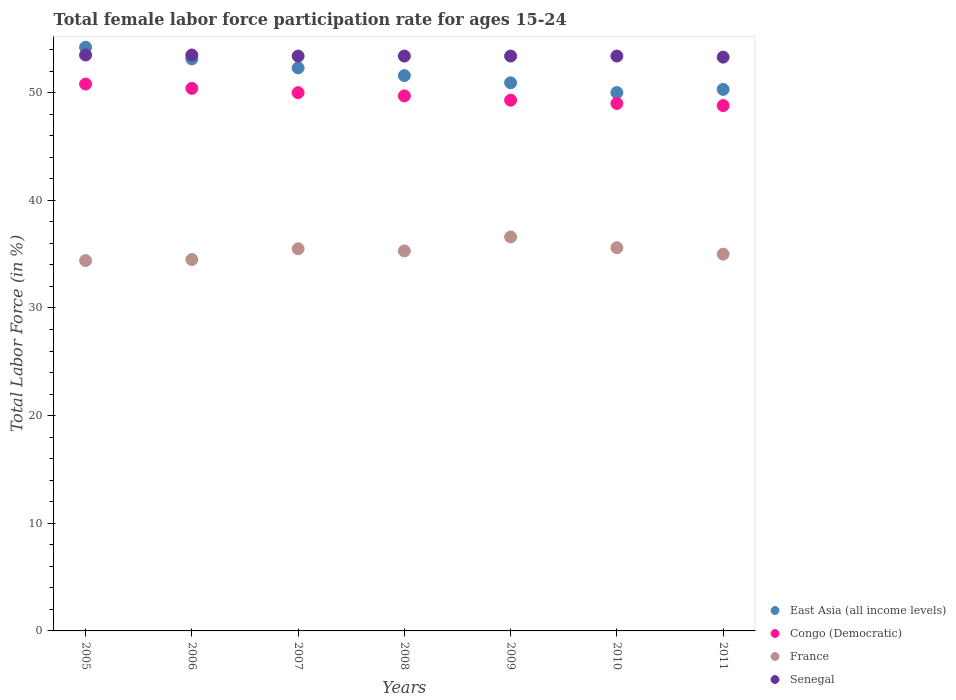How many different coloured dotlines are there?
Ensure brevity in your answer.  4. What is the female labor force participation rate in France in 2010?
Ensure brevity in your answer.  35.6. Across all years, what is the maximum female labor force participation rate in Senegal?
Ensure brevity in your answer.  53.5. Across all years, what is the minimum female labor force participation rate in France?
Give a very brief answer. 34.4. In which year was the female labor force participation rate in France maximum?
Keep it short and to the point. 2009. What is the total female labor force participation rate in France in the graph?
Your response must be concise. 246.9. What is the difference between the female labor force participation rate in Congo (Democratic) in 2005 and that in 2007?
Your response must be concise. 0.8. What is the difference between the female labor force participation rate in East Asia (all income levels) in 2010 and the female labor force participation rate in France in 2008?
Your response must be concise. 14.71. What is the average female labor force participation rate in Senegal per year?
Ensure brevity in your answer.  53.41. In the year 2011, what is the difference between the female labor force participation rate in Congo (Democratic) and female labor force participation rate in France?
Provide a short and direct response. 13.8. In how many years, is the female labor force participation rate in East Asia (all income levels) greater than 48 %?
Your response must be concise. 7. What is the ratio of the female labor force participation rate in Congo (Democratic) in 2005 to that in 2011?
Ensure brevity in your answer.  1.04. Is the difference between the female labor force participation rate in Congo (Democratic) in 2006 and 2007 greater than the difference between the female labor force participation rate in France in 2006 and 2007?
Offer a very short reply. Yes. What is the difference between the highest and the lowest female labor force participation rate in Congo (Democratic)?
Provide a short and direct response. 2. Is it the case that in every year, the sum of the female labor force participation rate in Senegal and female labor force participation rate in France  is greater than the female labor force participation rate in East Asia (all income levels)?
Give a very brief answer. Yes. Is the female labor force participation rate in East Asia (all income levels) strictly greater than the female labor force participation rate in Senegal over the years?
Keep it short and to the point. No. Is the female labor force participation rate in East Asia (all income levels) strictly less than the female labor force participation rate in France over the years?
Keep it short and to the point. No. How many dotlines are there?
Offer a very short reply. 4. What is the difference between two consecutive major ticks on the Y-axis?
Your answer should be compact. 10. Where does the legend appear in the graph?
Make the answer very short. Bottom right. How many legend labels are there?
Your response must be concise. 4. What is the title of the graph?
Give a very brief answer. Total female labor force participation rate for ages 15-24. What is the label or title of the X-axis?
Make the answer very short. Years. What is the label or title of the Y-axis?
Your answer should be very brief. Total Labor Force (in %). What is the Total Labor Force (in %) in East Asia (all income levels) in 2005?
Provide a succinct answer. 54.22. What is the Total Labor Force (in %) in Congo (Democratic) in 2005?
Your response must be concise. 50.8. What is the Total Labor Force (in %) of France in 2005?
Provide a succinct answer. 34.4. What is the Total Labor Force (in %) in Senegal in 2005?
Your answer should be compact. 53.5. What is the Total Labor Force (in %) in East Asia (all income levels) in 2006?
Ensure brevity in your answer.  53.13. What is the Total Labor Force (in %) of Congo (Democratic) in 2006?
Make the answer very short. 50.4. What is the Total Labor Force (in %) in France in 2006?
Your response must be concise. 34.5. What is the Total Labor Force (in %) of Senegal in 2006?
Your response must be concise. 53.5. What is the Total Labor Force (in %) of East Asia (all income levels) in 2007?
Make the answer very short. 52.3. What is the Total Labor Force (in %) in France in 2007?
Your answer should be very brief. 35.5. What is the Total Labor Force (in %) in Senegal in 2007?
Your answer should be compact. 53.4. What is the Total Labor Force (in %) in East Asia (all income levels) in 2008?
Provide a succinct answer. 51.59. What is the Total Labor Force (in %) of Congo (Democratic) in 2008?
Your answer should be compact. 49.7. What is the Total Labor Force (in %) in France in 2008?
Give a very brief answer. 35.3. What is the Total Labor Force (in %) in Senegal in 2008?
Your answer should be very brief. 53.4. What is the Total Labor Force (in %) of East Asia (all income levels) in 2009?
Offer a very short reply. 50.92. What is the Total Labor Force (in %) in Congo (Democratic) in 2009?
Keep it short and to the point. 49.3. What is the Total Labor Force (in %) of France in 2009?
Provide a short and direct response. 36.6. What is the Total Labor Force (in %) in Senegal in 2009?
Keep it short and to the point. 53.4. What is the Total Labor Force (in %) in East Asia (all income levels) in 2010?
Provide a succinct answer. 50.01. What is the Total Labor Force (in %) of Congo (Democratic) in 2010?
Your answer should be very brief. 49. What is the Total Labor Force (in %) of France in 2010?
Offer a very short reply. 35.6. What is the Total Labor Force (in %) in Senegal in 2010?
Ensure brevity in your answer.  53.4. What is the Total Labor Force (in %) in East Asia (all income levels) in 2011?
Ensure brevity in your answer.  50.31. What is the Total Labor Force (in %) of Congo (Democratic) in 2011?
Your response must be concise. 48.8. What is the Total Labor Force (in %) of France in 2011?
Provide a succinct answer. 35. What is the Total Labor Force (in %) in Senegal in 2011?
Provide a short and direct response. 53.3. Across all years, what is the maximum Total Labor Force (in %) in East Asia (all income levels)?
Ensure brevity in your answer.  54.22. Across all years, what is the maximum Total Labor Force (in %) of Congo (Democratic)?
Provide a short and direct response. 50.8. Across all years, what is the maximum Total Labor Force (in %) of France?
Ensure brevity in your answer.  36.6. Across all years, what is the maximum Total Labor Force (in %) in Senegal?
Provide a short and direct response. 53.5. Across all years, what is the minimum Total Labor Force (in %) of East Asia (all income levels)?
Your answer should be compact. 50.01. Across all years, what is the minimum Total Labor Force (in %) of Congo (Democratic)?
Offer a terse response. 48.8. Across all years, what is the minimum Total Labor Force (in %) in France?
Ensure brevity in your answer.  34.4. Across all years, what is the minimum Total Labor Force (in %) in Senegal?
Keep it short and to the point. 53.3. What is the total Total Labor Force (in %) in East Asia (all income levels) in the graph?
Provide a succinct answer. 362.47. What is the total Total Labor Force (in %) of Congo (Democratic) in the graph?
Your response must be concise. 348. What is the total Total Labor Force (in %) in France in the graph?
Offer a terse response. 246.9. What is the total Total Labor Force (in %) of Senegal in the graph?
Your answer should be compact. 373.9. What is the difference between the Total Labor Force (in %) of East Asia (all income levels) in 2005 and that in 2006?
Your answer should be very brief. 1.08. What is the difference between the Total Labor Force (in %) of Congo (Democratic) in 2005 and that in 2006?
Provide a succinct answer. 0.4. What is the difference between the Total Labor Force (in %) in Senegal in 2005 and that in 2006?
Make the answer very short. 0. What is the difference between the Total Labor Force (in %) of East Asia (all income levels) in 2005 and that in 2007?
Offer a terse response. 1.92. What is the difference between the Total Labor Force (in %) in France in 2005 and that in 2007?
Offer a terse response. -1.1. What is the difference between the Total Labor Force (in %) of East Asia (all income levels) in 2005 and that in 2008?
Give a very brief answer. 2.63. What is the difference between the Total Labor Force (in %) in Senegal in 2005 and that in 2008?
Make the answer very short. 0.1. What is the difference between the Total Labor Force (in %) of East Asia (all income levels) in 2005 and that in 2009?
Your response must be concise. 3.3. What is the difference between the Total Labor Force (in %) in Congo (Democratic) in 2005 and that in 2009?
Offer a terse response. 1.5. What is the difference between the Total Labor Force (in %) of Senegal in 2005 and that in 2009?
Make the answer very short. 0.1. What is the difference between the Total Labor Force (in %) in East Asia (all income levels) in 2005 and that in 2010?
Ensure brevity in your answer.  4.21. What is the difference between the Total Labor Force (in %) in France in 2005 and that in 2010?
Offer a terse response. -1.2. What is the difference between the Total Labor Force (in %) of Senegal in 2005 and that in 2010?
Your answer should be very brief. 0.1. What is the difference between the Total Labor Force (in %) of East Asia (all income levels) in 2005 and that in 2011?
Your answer should be compact. 3.91. What is the difference between the Total Labor Force (in %) of Congo (Democratic) in 2005 and that in 2011?
Provide a succinct answer. 2. What is the difference between the Total Labor Force (in %) of France in 2005 and that in 2011?
Ensure brevity in your answer.  -0.6. What is the difference between the Total Labor Force (in %) of East Asia (all income levels) in 2006 and that in 2007?
Offer a terse response. 0.84. What is the difference between the Total Labor Force (in %) of France in 2006 and that in 2007?
Provide a succinct answer. -1. What is the difference between the Total Labor Force (in %) of Senegal in 2006 and that in 2007?
Offer a terse response. 0.1. What is the difference between the Total Labor Force (in %) of East Asia (all income levels) in 2006 and that in 2008?
Offer a very short reply. 1.55. What is the difference between the Total Labor Force (in %) in Congo (Democratic) in 2006 and that in 2008?
Give a very brief answer. 0.7. What is the difference between the Total Labor Force (in %) of France in 2006 and that in 2008?
Your answer should be very brief. -0.8. What is the difference between the Total Labor Force (in %) in Senegal in 2006 and that in 2008?
Your answer should be very brief. 0.1. What is the difference between the Total Labor Force (in %) of East Asia (all income levels) in 2006 and that in 2009?
Provide a succinct answer. 2.22. What is the difference between the Total Labor Force (in %) of Congo (Democratic) in 2006 and that in 2009?
Offer a terse response. 1.1. What is the difference between the Total Labor Force (in %) of France in 2006 and that in 2009?
Make the answer very short. -2.1. What is the difference between the Total Labor Force (in %) in Senegal in 2006 and that in 2009?
Give a very brief answer. 0.1. What is the difference between the Total Labor Force (in %) in East Asia (all income levels) in 2006 and that in 2010?
Offer a terse response. 3.13. What is the difference between the Total Labor Force (in %) of France in 2006 and that in 2010?
Provide a short and direct response. -1.1. What is the difference between the Total Labor Force (in %) of East Asia (all income levels) in 2006 and that in 2011?
Your answer should be compact. 2.83. What is the difference between the Total Labor Force (in %) in Senegal in 2006 and that in 2011?
Provide a short and direct response. 0.2. What is the difference between the Total Labor Force (in %) in East Asia (all income levels) in 2007 and that in 2008?
Your answer should be very brief. 0.71. What is the difference between the Total Labor Force (in %) in Congo (Democratic) in 2007 and that in 2008?
Offer a very short reply. 0.3. What is the difference between the Total Labor Force (in %) of Senegal in 2007 and that in 2008?
Your answer should be very brief. 0. What is the difference between the Total Labor Force (in %) in East Asia (all income levels) in 2007 and that in 2009?
Your response must be concise. 1.38. What is the difference between the Total Labor Force (in %) of East Asia (all income levels) in 2007 and that in 2010?
Ensure brevity in your answer.  2.29. What is the difference between the Total Labor Force (in %) of Congo (Democratic) in 2007 and that in 2010?
Provide a short and direct response. 1. What is the difference between the Total Labor Force (in %) in France in 2007 and that in 2010?
Your answer should be very brief. -0.1. What is the difference between the Total Labor Force (in %) in East Asia (all income levels) in 2007 and that in 2011?
Your answer should be compact. 1.99. What is the difference between the Total Labor Force (in %) of Congo (Democratic) in 2007 and that in 2011?
Provide a succinct answer. 1.2. What is the difference between the Total Labor Force (in %) of East Asia (all income levels) in 2008 and that in 2009?
Make the answer very short. 0.67. What is the difference between the Total Labor Force (in %) in France in 2008 and that in 2009?
Your answer should be very brief. -1.3. What is the difference between the Total Labor Force (in %) of East Asia (all income levels) in 2008 and that in 2010?
Keep it short and to the point. 1.58. What is the difference between the Total Labor Force (in %) of East Asia (all income levels) in 2008 and that in 2011?
Your answer should be compact. 1.28. What is the difference between the Total Labor Force (in %) in Congo (Democratic) in 2008 and that in 2011?
Offer a terse response. 0.9. What is the difference between the Total Labor Force (in %) of East Asia (all income levels) in 2009 and that in 2010?
Your answer should be compact. 0.91. What is the difference between the Total Labor Force (in %) in Congo (Democratic) in 2009 and that in 2010?
Give a very brief answer. 0.3. What is the difference between the Total Labor Force (in %) in France in 2009 and that in 2010?
Your answer should be compact. 1. What is the difference between the Total Labor Force (in %) in Senegal in 2009 and that in 2010?
Offer a terse response. 0. What is the difference between the Total Labor Force (in %) in East Asia (all income levels) in 2009 and that in 2011?
Your answer should be compact. 0.61. What is the difference between the Total Labor Force (in %) of France in 2009 and that in 2011?
Ensure brevity in your answer.  1.6. What is the difference between the Total Labor Force (in %) of Senegal in 2009 and that in 2011?
Keep it short and to the point. 0.1. What is the difference between the Total Labor Force (in %) in East Asia (all income levels) in 2010 and that in 2011?
Make the answer very short. -0.3. What is the difference between the Total Labor Force (in %) in France in 2010 and that in 2011?
Your answer should be compact. 0.6. What is the difference between the Total Labor Force (in %) of Senegal in 2010 and that in 2011?
Your response must be concise. 0.1. What is the difference between the Total Labor Force (in %) of East Asia (all income levels) in 2005 and the Total Labor Force (in %) of Congo (Democratic) in 2006?
Offer a terse response. 3.82. What is the difference between the Total Labor Force (in %) in East Asia (all income levels) in 2005 and the Total Labor Force (in %) in France in 2006?
Make the answer very short. 19.72. What is the difference between the Total Labor Force (in %) of East Asia (all income levels) in 2005 and the Total Labor Force (in %) of Senegal in 2006?
Offer a terse response. 0.72. What is the difference between the Total Labor Force (in %) of Congo (Democratic) in 2005 and the Total Labor Force (in %) of Senegal in 2006?
Provide a short and direct response. -2.7. What is the difference between the Total Labor Force (in %) of France in 2005 and the Total Labor Force (in %) of Senegal in 2006?
Your answer should be very brief. -19.1. What is the difference between the Total Labor Force (in %) of East Asia (all income levels) in 2005 and the Total Labor Force (in %) of Congo (Democratic) in 2007?
Provide a succinct answer. 4.22. What is the difference between the Total Labor Force (in %) in East Asia (all income levels) in 2005 and the Total Labor Force (in %) in France in 2007?
Offer a very short reply. 18.72. What is the difference between the Total Labor Force (in %) in East Asia (all income levels) in 2005 and the Total Labor Force (in %) in Senegal in 2007?
Give a very brief answer. 0.82. What is the difference between the Total Labor Force (in %) in Congo (Democratic) in 2005 and the Total Labor Force (in %) in France in 2007?
Keep it short and to the point. 15.3. What is the difference between the Total Labor Force (in %) of East Asia (all income levels) in 2005 and the Total Labor Force (in %) of Congo (Democratic) in 2008?
Make the answer very short. 4.52. What is the difference between the Total Labor Force (in %) of East Asia (all income levels) in 2005 and the Total Labor Force (in %) of France in 2008?
Ensure brevity in your answer.  18.92. What is the difference between the Total Labor Force (in %) in East Asia (all income levels) in 2005 and the Total Labor Force (in %) in Senegal in 2008?
Offer a terse response. 0.82. What is the difference between the Total Labor Force (in %) in Congo (Democratic) in 2005 and the Total Labor Force (in %) in Senegal in 2008?
Keep it short and to the point. -2.6. What is the difference between the Total Labor Force (in %) in East Asia (all income levels) in 2005 and the Total Labor Force (in %) in Congo (Democratic) in 2009?
Make the answer very short. 4.92. What is the difference between the Total Labor Force (in %) of East Asia (all income levels) in 2005 and the Total Labor Force (in %) of France in 2009?
Your answer should be compact. 17.62. What is the difference between the Total Labor Force (in %) in East Asia (all income levels) in 2005 and the Total Labor Force (in %) in Senegal in 2009?
Provide a succinct answer. 0.82. What is the difference between the Total Labor Force (in %) in East Asia (all income levels) in 2005 and the Total Labor Force (in %) in Congo (Democratic) in 2010?
Ensure brevity in your answer.  5.22. What is the difference between the Total Labor Force (in %) of East Asia (all income levels) in 2005 and the Total Labor Force (in %) of France in 2010?
Your answer should be very brief. 18.62. What is the difference between the Total Labor Force (in %) of East Asia (all income levels) in 2005 and the Total Labor Force (in %) of Senegal in 2010?
Give a very brief answer. 0.82. What is the difference between the Total Labor Force (in %) of Congo (Democratic) in 2005 and the Total Labor Force (in %) of France in 2010?
Offer a terse response. 15.2. What is the difference between the Total Labor Force (in %) in France in 2005 and the Total Labor Force (in %) in Senegal in 2010?
Make the answer very short. -19. What is the difference between the Total Labor Force (in %) of East Asia (all income levels) in 2005 and the Total Labor Force (in %) of Congo (Democratic) in 2011?
Keep it short and to the point. 5.42. What is the difference between the Total Labor Force (in %) in East Asia (all income levels) in 2005 and the Total Labor Force (in %) in France in 2011?
Make the answer very short. 19.22. What is the difference between the Total Labor Force (in %) of East Asia (all income levels) in 2005 and the Total Labor Force (in %) of Senegal in 2011?
Offer a very short reply. 0.92. What is the difference between the Total Labor Force (in %) in Congo (Democratic) in 2005 and the Total Labor Force (in %) in France in 2011?
Provide a succinct answer. 15.8. What is the difference between the Total Labor Force (in %) of Congo (Democratic) in 2005 and the Total Labor Force (in %) of Senegal in 2011?
Give a very brief answer. -2.5. What is the difference between the Total Labor Force (in %) in France in 2005 and the Total Labor Force (in %) in Senegal in 2011?
Your response must be concise. -18.9. What is the difference between the Total Labor Force (in %) of East Asia (all income levels) in 2006 and the Total Labor Force (in %) of Congo (Democratic) in 2007?
Keep it short and to the point. 3.13. What is the difference between the Total Labor Force (in %) of East Asia (all income levels) in 2006 and the Total Labor Force (in %) of France in 2007?
Offer a terse response. 17.63. What is the difference between the Total Labor Force (in %) in East Asia (all income levels) in 2006 and the Total Labor Force (in %) in Senegal in 2007?
Ensure brevity in your answer.  -0.27. What is the difference between the Total Labor Force (in %) of Congo (Democratic) in 2006 and the Total Labor Force (in %) of France in 2007?
Give a very brief answer. 14.9. What is the difference between the Total Labor Force (in %) of France in 2006 and the Total Labor Force (in %) of Senegal in 2007?
Make the answer very short. -18.9. What is the difference between the Total Labor Force (in %) of East Asia (all income levels) in 2006 and the Total Labor Force (in %) of Congo (Democratic) in 2008?
Your response must be concise. 3.43. What is the difference between the Total Labor Force (in %) of East Asia (all income levels) in 2006 and the Total Labor Force (in %) of France in 2008?
Provide a short and direct response. 17.83. What is the difference between the Total Labor Force (in %) in East Asia (all income levels) in 2006 and the Total Labor Force (in %) in Senegal in 2008?
Your response must be concise. -0.27. What is the difference between the Total Labor Force (in %) of Congo (Democratic) in 2006 and the Total Labor Force (in %) of Senegal in 2008?
Provide a short and direct response. -3. What is the difference between the Total Labor Force (in %) in France in 2006 and the Total Labor Force (in %) in Senegal in 2008?
Keep it short and to the point. -18.9. What is the difference between the Total Labor Force (in %) in East Asia (all income levels) in 2006 and the Total Labor Force (in %) in Congo (Democratic) in 2009?
Give a very brief answer. 3.83. What is the difference between the Total Labor Force (in %) of East Asia (all income levels) in 2006 and the Total Labor Force (in %) of France in 2009?
Your response must be concise. 16.53. What is the difference between the Total Labor Force (in %) of East Asia (all income levels) in 2006 and the Total Labor Force (in %) of Senegal in 2009?
Ensure brevity in your answer.  -0.27. What is the difference between the Total Labor Force (in %) in Congo (Democratic) in 2006 and the Total Labor Force (in %) in France in 2009?
Keep it short and to the point. 13.8. What is the difference between the Total Labor Force (in %) in France in 2006 and the Total Labor Force (in %) in Senegal in 2009?
Provide a succinct answer. -18.9. What is the difference between the Total Labor Force (in %) in East Asia (all income levels) in 2006 and the Total Labor Force (in %) in Congo (Democratic) in 2010?
Keep it short and to the point. 4.13. What is the difference between the Total Labor Force (in %) in East Asia (all income levels) in 2006 and the Total Labor Force (in %) in France in 2010?
Your answer should be compact. 17.53. What is the difference between the Total Labor Force (in %) of East Asia (all income levels) in 2006 and the Total Labor Force (in %) of Senegal in 2010?
Keep it short and to the point. -0.27. What is the difference between the Total Labor Force (in %) in France in 2006 and the Total Labor Force (in %) in Senegal in 2010?
Provide a succinct answer. -18.9. What is the difference between the Total Labor Force (in %) in East Asia (all income levels) in 2006 and the Total Labor Force (in %) in Congo (Democratic) in 2011?
Offer a terse response. 4.33. What is the difference between the Total Labor Force (in %) of East Asia (all income levels) in 2006 and the Total Labor Force (in %) of France in 2011?
Give a very brief answer. 18.13. What is the difference between the Total Labor Force (in %) of East Asia (all income levels) in 2006 and the Total Labor Force (in %) of Senegal in 2011?
Make the answer very short. -0.17. What is the difference between the Total Labor Force (in %) in France in 2006 and the Total Labor Force (in %) in Senegal in 2011?
Provide a succinct answer. -18.8. What is the difference between the Total Labor Force (in %) of East Asia (all income levels) in 2007 and the Total Labor Force (in %) of Congo (Democratic) in 2008?
Keep it short and to the point. 2.6. What is the difference between the Total Labor Force (in %) in East Asia (all income levels) in 2007 and the Total Labor Force (in %) in France in 2008?
Keep it short and to the point. 17. What is the difference between the Total Labor Force (in %) in East Asia (all income levels) in 2007 and the Total Labor Force (in %) in Senegal in 2008?
Your answer should be compact. -1.1. What is the difference between the Total Labor Force (in %) in Congo (Democratic) in 2007 and the Total Labor Force (in %) in France in 2008?
Offer a terse response. 14.7. What is the difference between the Total Labor Force (in %) in Congo (Democratic) in 2007 and the Total Labor Force (in %) in Senegal in 2008?
Ensure brevity in your answer.  -3.4. What is the difference between the Total Labor Force (in %) of France in 2007 and the Total Labor Force (in %) of Senegal in 2008?
Your answer should be compact. -17.9. What is the difference between the Total Labor Force (in %) of East Asia (all income levels) in 2007 and the Total Labor Force (in %) of Congo (Democratic) in 2009?
Your response must be concise. 3. What is the difference between the Total Labor Force (in %) of East Asia (all income levels) in 2007 and the Total Labor Force (in %) of France in 2009?
Make the answer very short. 15.7. What is the difference between the Total Labor Force (in %) in East Asia (all income levels) in 2007 and the Total Labor Force (in %) in Senegal in 2009?
Offer a terse response. -1.1. What is the difference between the Total Labor Force (in %) of Congo (Democratic) in 2007 and the Total Labor Force (in %) of France in 2009?
Offer a very short reply. 13.4. What is the difference between the Total Labor Force (in %) in France in 2007 and the Total Labor Force (in %) in Senegal in 2009?
Keep it short and to the point. -17.9. What is the difference between the Total Labor Force (in %) of East Asia (all income levels) in 2007 and the Total Labor Force (in %) of Congo (Democratic) in 2010?
Give a very brief answer. 3.3. What is the difference between the Total Labor Force (in %) in East Asia (all income levels) in 2007 and the Total Labor Force (in %) in France in 2010?
Your answer should be very brief. 16.7. What is the difference between the Total Labor Force (in %) in East Asia (all income levels) in 2007 and the Total Labor Force (in %) in Senegal in 2010?
Ensure brevity in your answer.  -1.1. What is the difference between the Total Labor Force (in %) in France in 2007 and the Total Labor Force (in %) in Senegal in 2010?
Your answer should be compact. -17.9. What is the difference between the Total Labor Force (in %) in East Asia (all income levels) in 2007 and the Total Labor Force (in %) in Congo (Democratic) in 2011?
Your answer should be compact. 3.5. What is the difference between the Total Labor Force (in %) in East Asia (all income levels) in 2007 and the Total Labor Force (in %) in France in 2011?
Give a very brief answer. 17.3. What is the difference between the Total Labor Force (in %) of East Asia (all income levels) in 2007 and the Total Labor Force (in %) of Senegal in 2011?
Your answer should be compact. -1. What is the difference between the Total Labor Force (in %) of France in 2007 and the Total Labor Force (in %) of Senegal in 2011?
Your response must be concise. -17.8. What is the difference between the Total Labor Force (in %) of East Asia (all income levels) in 2008 and the Total Labor Force (in %) of Congo (Democratic) in 2009?
Offer a terse response. 2.29. What is the difference between the Total Labor Force (in %) in East Asia (all income levels) in 2008 and the Total Labor Force (in %) in France in 2009?
Your response must be concise. 14.99. What is the difference between the Total Labor Force (in %) in East Asia (all income levels) in 2008 and the Total Labor Force (in %) in Senegal in 2009?
Give a very brief answer. -1.81. What is the difference between the Total Labor Force (in %) of Congo (Democratic) in 2008 and the Total Labor Force (in %) of France in 2009?
Your answer should be compact. 13.1. What is the difference between the Total Labor Force (in %) of France in 2008 and the Total Labor Force (in %) of Senegal in 2009?
Your answer should be compact. -18.1. What is the difference between the Total Labor Force (in %) of East Asia (all income levels) in 2008 and the Total Labor Force (in %) of Congo (Democratic) in 2010?
Provide a succinct answer. 2.59. What is the difference between the Total Labor Force (in %) in East Asia (all income levels) in 2008 and the Total Labor Force (in %) in France in 2010?
Your response must be concise. 15.99. What is the difference between the Total Labor Force (in %) in East Asia (all income levels) in 2008 and the Total Labor Force (in %) in Senegal in 2010?
Give a very brief answer. -1.81. What is the difference between the Total Labor Force (in %) of France in 2008 and the Total Labor Force (in %) of Senegal in 2010?
Your response must be concise. -18.1. What is the difference between the Total Labor Force (in %) of East Asia (all income levels) in 2008 and the Total Labor Force (in %) of Congo (Democratic) in 2011?
Your answer should be compact. 2.79. What is the difference between the Total Labor Force (in %) in East Asia (all income levels) in 2008 and the Total Labor Force (in %) in France in 2011?
Keep it short and to the point. 16.59. What is the difference between the Total Labor Force (in %) in East Asia (all income levels) in 2008 and the Total Labor Force (in %) in Senegal in 2011?
Make the answer very short. -1.71. What is the difference between the Total Labor Force (in %) in East Asia (all income levels) in 2009 and the Total Labor Force (in %) in Congo (Democratic) in 2010?
Your answer should be compact. 1.92. What is the difference between the Total Labor Force (in %) in East Asia (all income levels) in 2009 and the Total Labor Force (in %) in France in 2010?
Provide a succinct answer. 15.32. What is the difference between the Total Labor Force (in %) in East Asia (all income levels) in 2009 and the Total Labor Force (in %) in Senegal in 2010?
Give a very brief answer. -2.48. What is the difference between the Total Labor Force (in %) in Congo (Democratic) in 2009 and the Total Labor Force (in %) in Senegal in 2010?
Provide a succinct answer. -4.1. What is the difference between the Total Labor Force (in %) of France in 2009 and the Total Labor Force (in %) of Senegal in 2010?
Give a very brief answer. -16.8. What is the difference between the Total Labor Force (in %) of East Asia (all income levels) in 2009 and the Total Labor Force (in %) of Congo (Democratic) in 2011?
Give a very brief answer. 2.12. What is the difference between the Total Labor Force (in %) in East Asia (all income levels) in 2009 and the Total Labor Force (in %) in France in 2011?
Your answer should be compact. 15.92. What is the difference between the Total Labor Force (in %) of East Asia (all income levels) in 2009 and the Total Labor Force (in %) of Senegal in 2011?
Your response must be concise. -2.38. What is the difference between the Total Labor Force (in %) of Congo (Democratic) in 2009 and the Total Labor Force (in %) of France in 2011?
Your answer should be compact. 14.3. What is the difference between the Total Labor Force (in %) in Congo (Democratic) in 2009 and the Total Labor Force (in %) in Senegal in 2011?
Offer a very short reply. -4. What is the difference between the Total Labor Force (in %) in France in 2009 and the Total Labor Force (in %) in Senegal in 2011?
Your response must be concise. -16.7. What is the difference between the Total Labor Force (in %) of East Asia (all income levels) in 2010 and the Total Labor Force (in %) of Congo (Democratic) in 2011?
Provide a succinct answer. 1.21. What is the difference between the Total Labor Force (in %) of East Asia (all income levels) in 2010 and the Total Labor Force (in %) of France in 2011?
Make the answer very short. 15.01. What is the difference between the Total Labor Force (in %) in East Asia (all income levels) in 2010 and the Total Labor Force (in %) in Senegal in 2011?
Offer a very short reply. -3.29. What is the difference between the Total Labor Force (in %) in Congo (Democratic) in 2010 and the Total Labor Force (in %) in France in 2011?
Your answer should be very brief. 14. What is the difference between the Total Labor Force (in %) of Congo (Democratic) in 2010 and the Total Labor Force (in %) of Senegal in 2011?
Your answer should be compact. -4.3. What is the difference between the Total Labor Force (in %) in France in 2010 and the Total Labor Force (in %) in Senegal in 2011?
Provide a short and direct response. -17.7. What is the average Total Labor Force (in %) in East Asia (all income levels) per year?
Your response must be concise. 51.78. What is the average Total Labor Force (in %) in Congo (Democratic) per year?
Your answer should be very brief. 49.71. What is the average Total Labor Force (in %) of France per year?
Ensure brevity in your answer.  35.27. What is the average Total Labor Force (in %) in Senegal per year?
Offer a terse response. 53.41. In the year 2005, what is the difference between the Total Labor Force (in %) of East Asia (all income levels) and Total Labor Force (in %) of Congo (Democratic)?
Provide a short and direct response. 3.42. In the year 2005, what is the difference between the Total Labor Force (in %) of East Asia (all income levels) and Total Labor Force (in %) of France?
Provide a succinct answer. 19.82. In the year 2005, what is the difference between the Total Labor Force (in %) in East Asia (all income levels) and Total Labor Force (in %) in Senegal?
Provide a succinct answer. 0.72. In the year 2005, what is the difference between the Total Labor Force (in %) of France and Total Labor Force (in %) of Senegal?
Your answer should be compact. -19.1. In the year 2006, what is the difference between the Total Labor Force (in %) of East Asia (all income levels) and Total Labor Force (in %) of Congo (Democratic)?
Provide a succinct answer. 2.73. In the year 2006, what is the difference between the Total Labor Force (in %) in East Asia (all income levels) and Total Labor Force (in %) in France?
Give a very brief answer. 18.63. In the year 2006, what is the difference between the Total Labor Force (in %) of East Asia (all income levels) and Total Labor Force (in %) of Senegal?
Provide a short and direct response. -0.37. In the year 2007, what is the difference between the Total Labor Force (in %) in East Asia (all income levels) and Total Labor Force (in %) in Congo (Democratic)?
Offer a terse response. 2.3. In the year 2007, what is the difference between the Total Labor Force (in %) of East Asia (all income levels) and Total Labor Force (in %) of France?
Provide a short and direct response. 16.8. In the year 2007, what is the difference between the Total Labor Force (in %) of East Asia (all income levels) and Total Labor Force (in %) of Senegal?
Give a very brief answer. -1.1. In the year 2007, what is the difference between the Total Labor Force (in %) of Congo (Democratic) and Total Labor Force (in %) of France?
Make the answer very short. 14.5. In the year 2007, what is the difference between the Total Labor Force (in %) of France and Total Labor Force (in %) of Senegal?
Your answer should be very brief. -17.9. In the year 2008, what is the difference between the Total Labor Force (in %) of East Asia (all income levels) and Total Labor Force (in %) of Congo (Democratic)?
Offer a terse response. 1.89. In the year 2008, what is the difference between the Total Labor Force (in %) in East Asia (all income levels) and Total Labor Force (in %) in France?
Offer a terse response. 16.29. In the year 2008, what is the difference between the Total Labor Force (in %) in East Asia (all income levels) and Total Labor Force (in %) in Senegal?
Give a very brief answer. -1.81. In the year 2008, what is the difference between the Total Labor Force (in %) of France and Total Labor Force (in %) of Senegal?
Make the answer very short. -18.1. In the year 2009, what is the difference between the Total Labor Force (in %) in East Asia (all income levels) and Total Labor Force (in %) in Congo (Democratic)?
Offer a terse response. 1.62. In the year 2009, what is the difference between the Total Labor Force (in %) in East Asia (all income levels) and Total Labor Force (in %) in France?
Provide a short and direct response. 14.32. In the year 2009, what is the difference between the Total Labor Force (in %) of East Asia (all income levels) and Total Labor Force (in %) of Senegal?
Keep it short and to the point. -2.48. In the year 2009, what is the difference between the Total Labor Force (in %) in Congo (Democratic) and Total Labor Force (in %) in France?
Offer a terse response. 12.7. In the year 2009, what is the difference between the Total Labor Force (in %) of Congo (Democratic) and Total Labor Force (in %) of Senegal?
Your response must be concise. -4.1. In the year 2009, what is the difference between the Total Labor Force (in %) in France and Total Labor Force (in %) in Senegal?
Your response must be concise. -16.8. In the year 2010, what is the difference between the Total Labor Force (in %) in East Asia (all income levels) and Total Labor Force (in %) in Congo (Democratic)?
Offer a very short reply. 1.01. In the year 2010, what is the difference between the Total Labor Force (in %) of East Asia (all income levels) and Total Labor Force (in %) of France?
Keep it short and to the point. 14.41. In the year 2010, what is the difference between the Total Labor Force (in %) of East Asia (all income levels) and Total Labor Force (in %) of Senegal?
Your answer should be compact. -3.39. In the year 2010, what is the difference between the Total Labor Force (in %) in Congo (Democratic) and Total Labor Force (in %) in Senegal?
Offer a terse response. -4.4. In the year 2010, what is the difference between the Total Labor Force (in %) of France and Total Labor Force (in %) of Senegal?
Keep it short and to the point. -17.8. In the year 2011, what is the difference between the Total Labor Force (in %) of East Asia (all income levels) and Total Labor Force (in %) of Congo (Democratic)?
Your answer should be compact. 1.51. In the year 2011, what is the difference between the Total Labor Force (in %) in East Asia (all income levels) and Total Labor Force (in %) in France?
Your answer should be very brief. 15.31. In the year 2011, what is the difference between the Total Labor Force (in %) in East Asia (all income levels) and Total Labor Force (in %) in Senegal?
Keep it short and to the point. -2.99. In the year 2011, what is the difference between the Total Labor Force (in %) in Congo (Democratic) and Total Labor Force (in %) in France?
Give a very brief answer. 13.8. In the year 2011, what is the difference between the Total Labor Force (in %) of Congo (Democratic) and Total Labor Force (in %) of Senegal?
Provide a succinct answer. -4.5. In the year 2011, what is the difference between the Total Labor Force (in %) in France and Total Labor Force (in %) in Senegal?
Provide a succinct answer. -18.3. What is the ratio of the Total Labor Force (in %) of East Asia (all income levels) in 2005 to that in 2006?
Offer a terse response. 1.02. What is the ratio of the Total Labor Force (in %) in Congo (Democratic) in 2005 to that in 2006?
Offer a terse response. 1.01. What is the ratio of the Total Labor Force (in %) of East Asia (all income levels) in 2005 to that in 2007?
Ensure brevity in your answer.  1.04. What is the ratio of the Total Labor Force (in %) of Senegal in 2005 to that in 2007?
Provide a short and direct response. 1. What is the ratio of the Total Labor Force (in %) of East Asia (all income levels) in 2005 to that in 2008?
Provide a succinct answer. 1.05. What is the ratio of the Total Labor Force (in %) in Congo (Democratic) in 2005 to that in 2008?
Provide a succinct answer. 1.02. What is the ratio of the Total Labor Force (in %) in France in 2005 to that in 2008?
Provide a succinct answer. 0.97. What is the ratio of the Total Labor Force (in %) in East Asia (all income levels) in 2005 to that in 2009?
Offer a very short reply. 1.06. What is the ratio of the Total Labor Force (in %) of Congo (Democratic) in 2005 to that in 2009?
Provide a short and direct response. 1.03. What is the ratio of the Total Labor Force (in %) of France in 2005 to that in 2009?
Make the answer very short. 0.94. What is the ratio of the Total Labor Force (in %) in Senegal in 2005 to that in 2009?
Give a very brief answer. 1. What is the ratio of the Total Labor Force (in %) of East Asia (all income levels) in 2005 to that in 2010?
Offer a very short reply. 1.08. What is the ratio of the Total Labor Force (in %) in Congo (Democratic) in 2005 to that in 2010?
Give a very brief answer. 1.04. What is the ratio of the Total Labor Force (in %) of France in 2005 to that in 2010?
Your answer should be compact. 0.97. What is the ratio of the Total Labor Force (in %) in Senegal in 2005 to that in 2010?
Provide a succinct answer. 1. What is the ratio of the Total Labor Force (in %) of East Asia (all income levels) in 2005 to that in 2011?
Keep it short and to the point. 1.08. What is the ratio of the Total Labor Force (in %) in Congo (Democratic) in 2005 to that in 2011?
Keep it short and to the point. 1.04. What is the ratio of the Total Labor Force (in %) in France in 2005 to that in 2011?
Ensure brevity in your answer.  0.98. What is the ratio of the Total Labor Force (in %) of Senegal in 2005 to that in 2011?
Your answer should be very brief. 1. What is the ratio of the Total Labor Force (in %) of Congo (Democratic) in 2006 to that in 2007?
Offer a terse response. 1.01. What is the ratio of the Total Labor Force (in %) of France in 2006 to that in 2007?
Offer a terse response. 0.97. What is the ratio of the Total Labor Force (in %) in East Asia (all income levels) in 2006 to that in 2008?
Provide a succinct answer. 1.03. What is the ratio of the Total Labor Force (in %) in Congo (Democratic) in 2006 to that in 2008?
Your answer should be very brief. 1.01. What is the ratio of the Total Labor Force (in %) of France in 2006 to that in 2008?
Offer a very short reply. 0.98. What is the ratio of the Total Labor Force (in %) of East Asia (all income levels) in 2006 to that in 2009?
Provide a succinct answer. 1.04. What is the ratio of the Total Labor Force (in %) of Congo (Democratic) in 2006 to that in 2009?
Make the answer very short. 1.02. What is the ratio of the Total Labor Force (in %) in France in 2006 to that in 2009?
Your answer should be very brief. 0.94. What is the ratio of the Total Labor Force (in %) of Senegal in 2006 to that in 2009?
Ensure brevity in your answer.  1. What is the ratio of the Total Labor Force (in %) in East Asia (all income levels) in 2006 to that in 2010?
Provide a short and direct response. 1.06. What is the ratio of the Total Labor Force (in %) of Congo (Democratic) in 2006 to that in 2010?
Ensure brevity in your answer.  1.03. What is the ratio of the Total Labor Force (in %) in France in 2006 to that in 2010?
Make the answer very short. 0.97. What is the ratio of the Total Labor Force (in %) in East Asia (all income levels) in 2006 to that in 2011?
Provide a short and direct response. 1.06. What is the ratio of the Total Labor Force (in %) in Congo (Democratic) in 2006 to that in 2011?
Your answer should be very brief. 1.03. What is the ratio of the Total Labor Force (in %) of France in 2006 to that in 2011?
Keep it short and to the point. 0.99. What is the ratio of the Total Labor Force (in %) of Senegal in 2006 to that in 2011?
Make the answer very short. 1. What is the ratio of the Total Labor Force (in %) in East Asia (all income levels) in 2007 to that in 2008?
Offer a terse response. 1.01. What is the ratio of the Total Labor Force (in %) of France in 2007 to that in 2008?
Your answer should be compact. 1.01. What is the ratio of the Total Labor Force (in %) of East Asia (all income levels) in 2007 to that in 2009?
Your answer should be compact. 1.03. What is the ratio of the Total Labor Force (in %) in Congo (Democratic) in 2007 to that in 2009?
Offer a terse response. 1.01. What is the ratio of the Total Labor Force (in %) of France in 2007 to that in 2009?
Keep it short and to the point. 0.97. What is the ratio of the Total Labor Force (in %) in Senegal in 2007 to that in 2009?
Ensure brevity in your answer.  1. What is the ratio of the Total Labor Force (in %) in East Asia (all income levels) in 2007 to that in 2010?
Make the answer very short. 1.05. What is the ratio of the Total Labor Force (in %) of Congo (Democratic) in 2007 to that in 2010?
Your answer should be compact. 1.02. What is the ratio of the Total Labor Force (in %) in France in 2007 to that in 2010?
Ensure brevity in your answer.  1. What is the ratio of the Total Labor Force (in %) of Senegal in 2007 to that in 2010?
Keep it short and to the point. 1. What is the ratio of the Total Labor Force (in %) of East Asia (all income levels) in 2007 to that in 2011?
Your answer should be compact. 1.04. What is the ratio of the Total Labor Force (in %) of Congo (Democratic) in 2007 to that in 2011?
Offer a terse response. 1.02. What is the ratio of the Total Labor Force (in %) in France in 2007 to that in 2011?
Provide a short and direct response. 1.01. What is the ratio of the Total Labor Force (in %) of Senegal in 2007 to that in 2011?
Ensure brevity in your answer.  1. What is the ratio of the Total Labor Force (in %) of East Asia (all income levels) in 2008 to that in 2009?
Ensure brevity in your answer.  1.01. What is the ratio of the Total Labor Force (in %) of France in 2008 to that in 2009?
Make the answer very short. 0.96. What is the ratio of the Total Labor Force (in %) in Senegal in 2008 to that in 2009?
Offer a terse response. 1. What is the ratio of the Total Labor Force (in %) of East Asia (all income levels) in 2008 to that in 2010?
Your answer should be very brief. 1.03. What is the ratio of the Total Labor Force (in %) of Congo (Democratic) in 2008 to that in 2010?
Give a very brief answer. 1.01. What is the ratio of the Total Labor Force (in %) of France in 2008 to that in 2010?
Provide a short and direct response. 0.99. What is the ratio of the Total Labor Force (in %) of Senegal in 2008 to that in 2010?
Give a very brief answer. 1. What is the ratio of the Total Labor Force (in %) in East Asia (all income levels) in 2008 to that in 2011?
Keep it short and to the point. 1.03. What is the ratio of the Total Labor Force (in %) in Congo (Democratic) in 2008 to that in 2011?
Offer a terse response. 1.02. What is the ratio of the Total Labor Force (in %) of France in 2008 to that in 2011?
Give a very brief answer. 1.01. What is the ratio of the Total Labor Force (in %) in East Asia (all income levels) in 2009 to that in 2010?
Provide a short and direct response. 1.02. What is the ratio of the Total Labor Force (in %) of Congo (Democratic) in 2009 to that in 2010?
Your answer should be compact. 1.01. What is the ratio of the Total Labor Force (in %) in France in 2009 to that in 2010?
Give a very brief answer. 1.03. What is the ratio of the Total Labor Force (in %) of East Asia (all income levels) in 2009 to that in 2011?
Give a very brief answer. 1.01. What is the ratio of the Total Labor Force (in %) in Congo (Democratic) in 2009 to that in 2011?
Keep it short and to the point. 1.01. What is the ratio of the Total Labor Force (in %) in France in 2009 to that in 2011?
Provide a short and direct response. 1.05. What is the ratio of the Total Labor Force (in %) in France in 2010 to that in 2011?
Your answer should be very brief. 1.02. What is the ratio of the Total Labor Force (in %) in Senegal in 2010 to that in 2011?
Make the answer very short. 1. What is the difference between the highest and the second highest Total Labor Force (in %) of East Asia (all income levels)?
Ensure brevity in your answer.  1.08. What is the difference between the highest and the second highest Total Labor Force (in %) of Congo (Democratic)?
Offer a terse response. 0.4. What is the difference between the highest and the second highest Total Labor Force (in %) of France?
Give a very brief answer. 1. What is the difference between the highest and the lowest Total Labor Force (in %) of East Asia (all income levels)?
Ensure brevity in your answer.  4.21. 